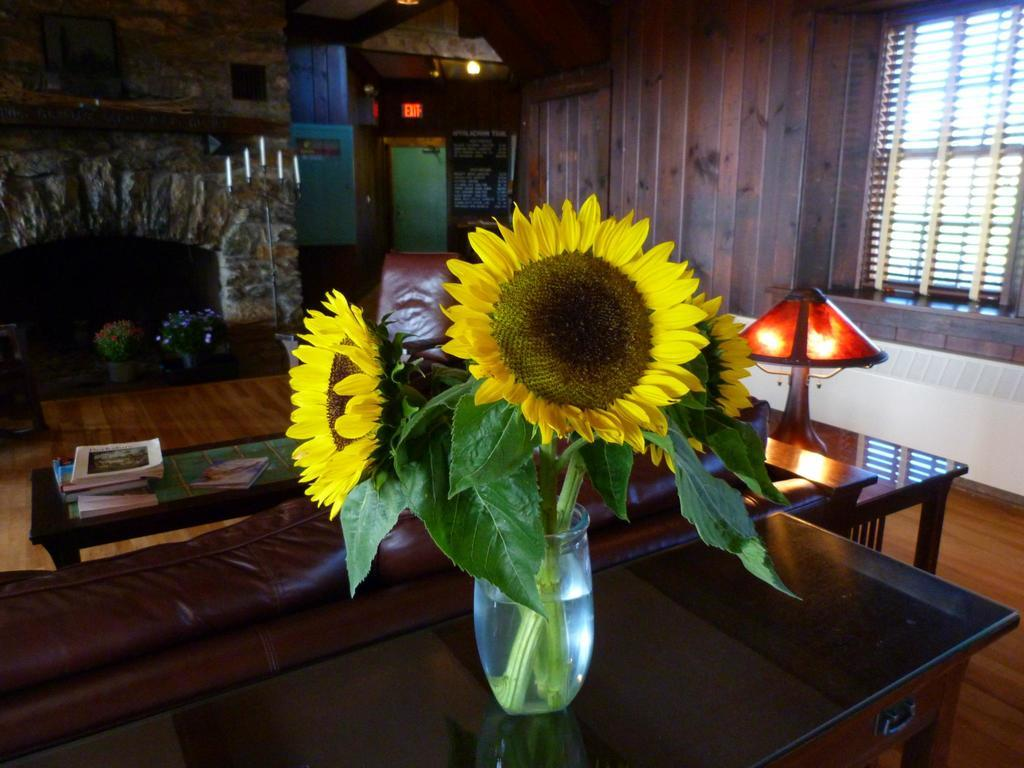What is placed on the table in the image? There is a vase with flowers on a table. What else can be seen on a table in the image? There are books on another table. What type of lighting is present in the image? There is a lamp in the image. What can be seen through the window in the image? The presence of a window suggests that there might be a view of the outdoors, but the specifics are not mentioned in the facts. How many birds are sitting on the tent in the image? There is no tent or birds present in the image. What type of doll is sitting on the windowsill in the image? There is no doll present in the image. 